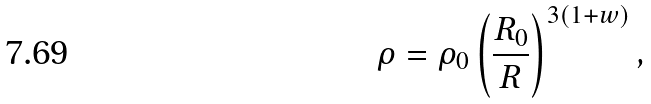Convert formula to latex. <formula><loc_0><loc_0><loc_500><loc_500>\rho = \rho _ { 0 } \left ( \frac { R _ { 0 } } { R } \right ) ^ { 3 \left ( 1 + w \right ) } ,</formula> 